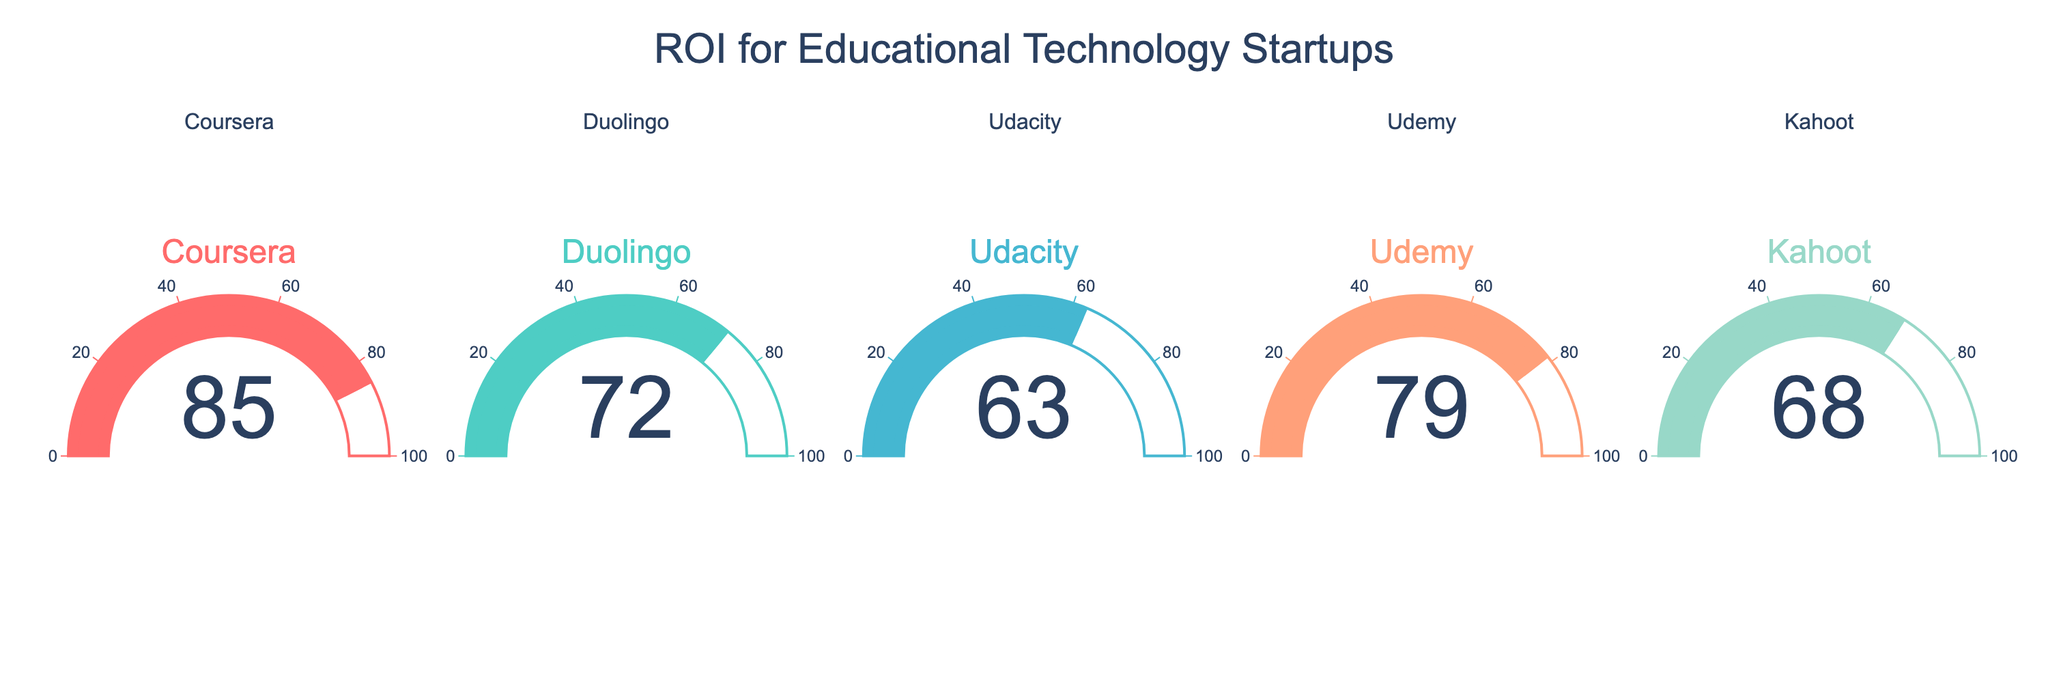What is the title of the figure? The title is displayed at the top of the figure in large text.
Answer: ROI for Educational Technology Startups How many companies are shown in the figure? There are individual gauges shown, each labeled with a company name. Counting the gauges gives the total number of companies.
Answer: 5 Which company has the highest ROI? Look at the values displayed in the center of each gauge for all companies. The highest number is the highest ROI.
Answer: Coursera What is the difference in ROI between Kahoot and Duolingo? Find the values for Kahoot and Duolingo from their respective gauges (68 and 72), and calculate the difference: 72 - 68.
Answer: 4 What is the average ROI of all the companies? Add up the ROI values for all companies and divide by the number of companies. (85 + 72 + 63 + 79 + 68) / 5 = 367 / 5 = 73.4
Answer: 73.4 Which company has an ROI closest to 70? Identify the values and see which one is closest to 70. Duolingo has an ROI of 72, which is the closest.
Answer: Duolingo Is Udacity's ROI greater than Kahoot's? Compare the numbers on Udacity's and Kahoot's gauges. Udacity has 63 and Kahoot has 68, thus 63 < 68.
Answer: No Rank the companies from highest to lowest ROI. List the companies in descending order based on the ROI values displayed.
Answer: Coursera > Udemy > Duolingo > Kahoot > Udacity 